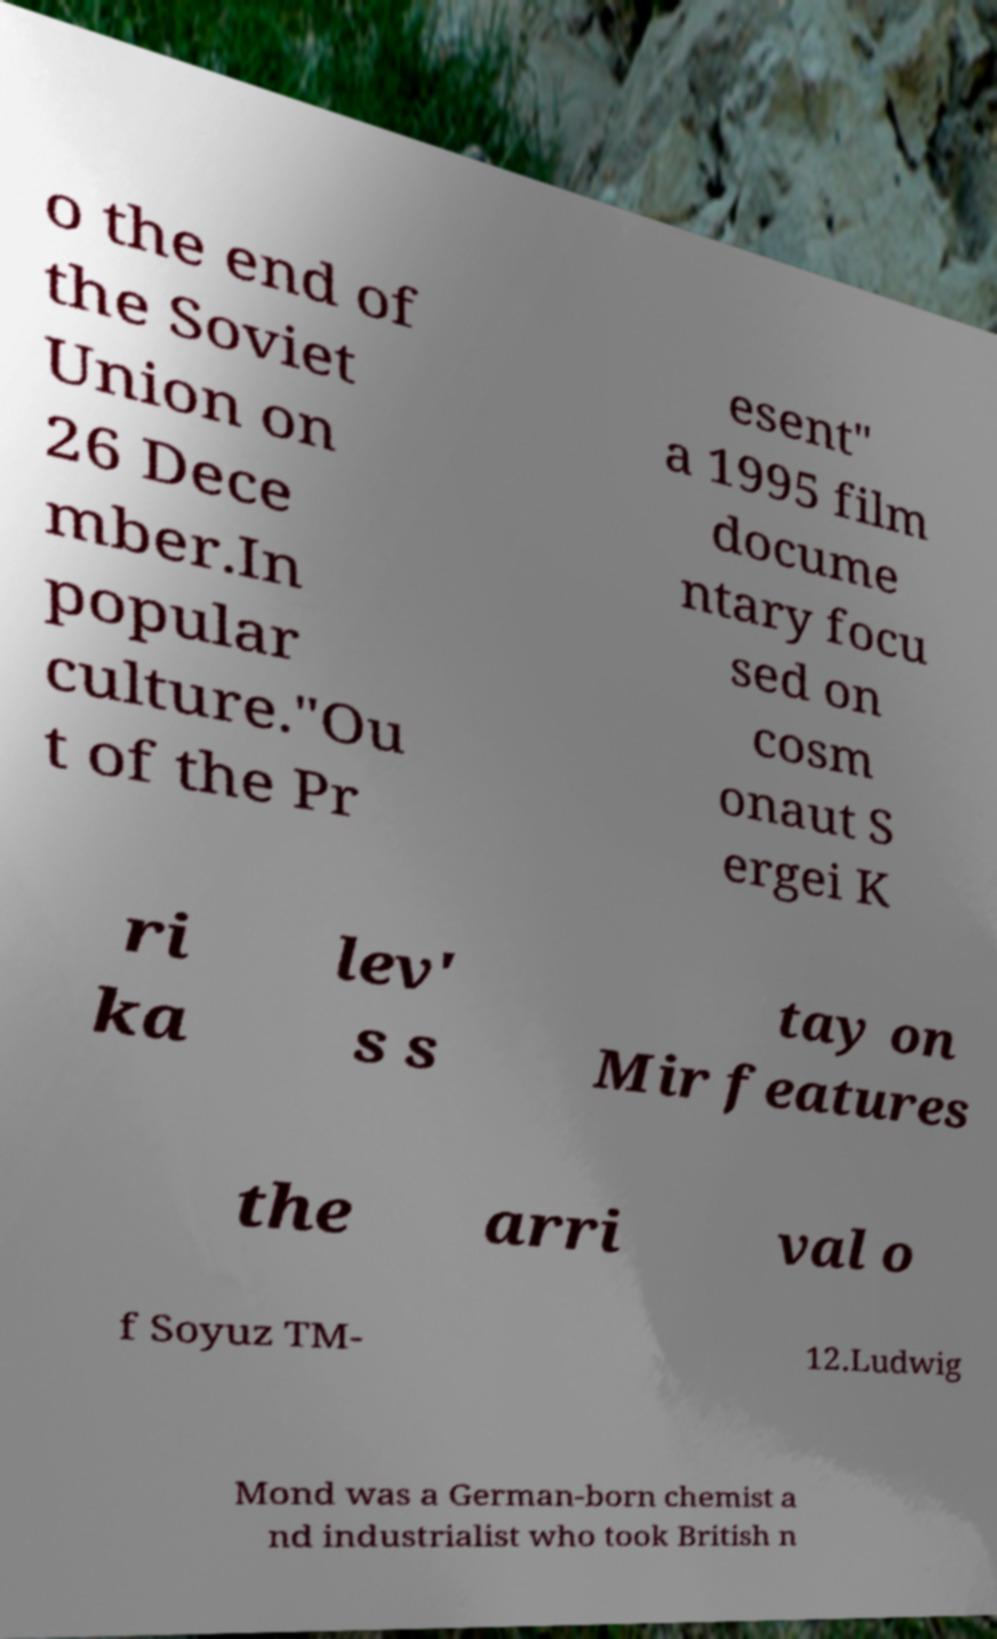I need the written content from this picture converted into text. Can you do that? o the end of the Soviet Union on 26 Dece mber.In popular culture."Ou t of the Pr esent" a 1995 film docume ntary focu sed on cosm onaut S ergei K ri ka lev' s s tay on Mir features the arri val o f Soyuz TM- 12.Ludwig Mond was a German-born chemist a nd industrialist who took British n 